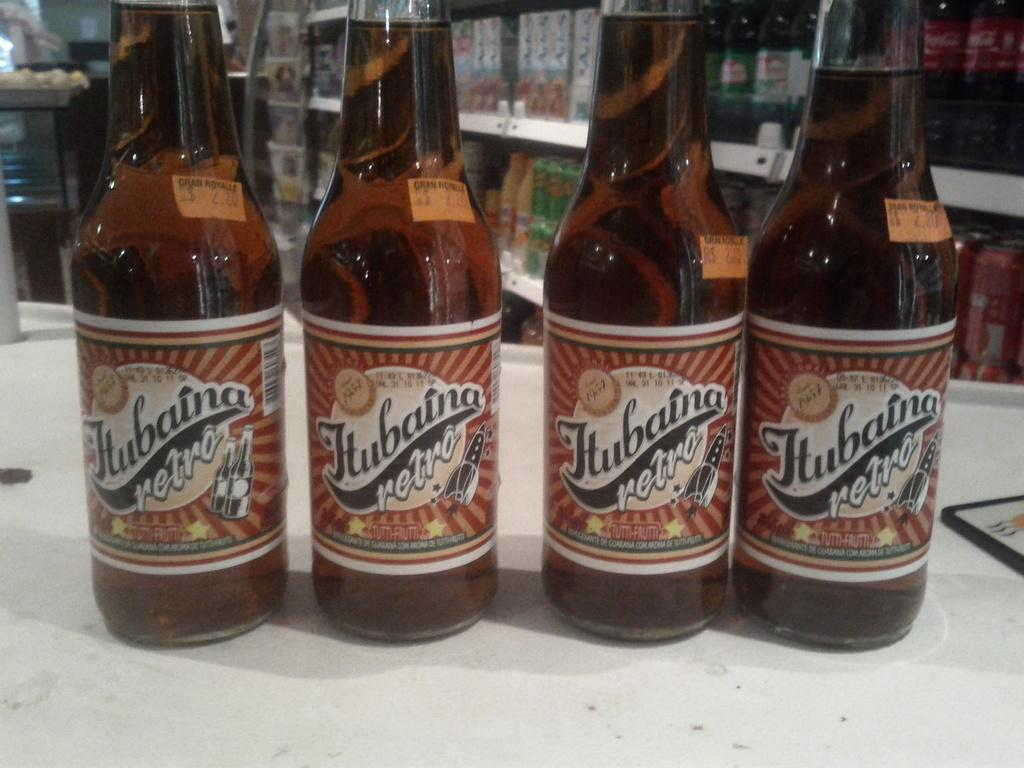<image>
Describe the image concisely. four bottles of retro drink are sitting side by side on a table 